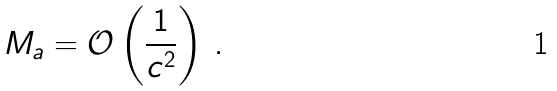<formula> <loc_0><loc_0><loc_500><loc_500>M _ { a } = \mathcal { O } \left ( \frac { 1 } { c ^ { 2 } } \right ) \, .</formula> 